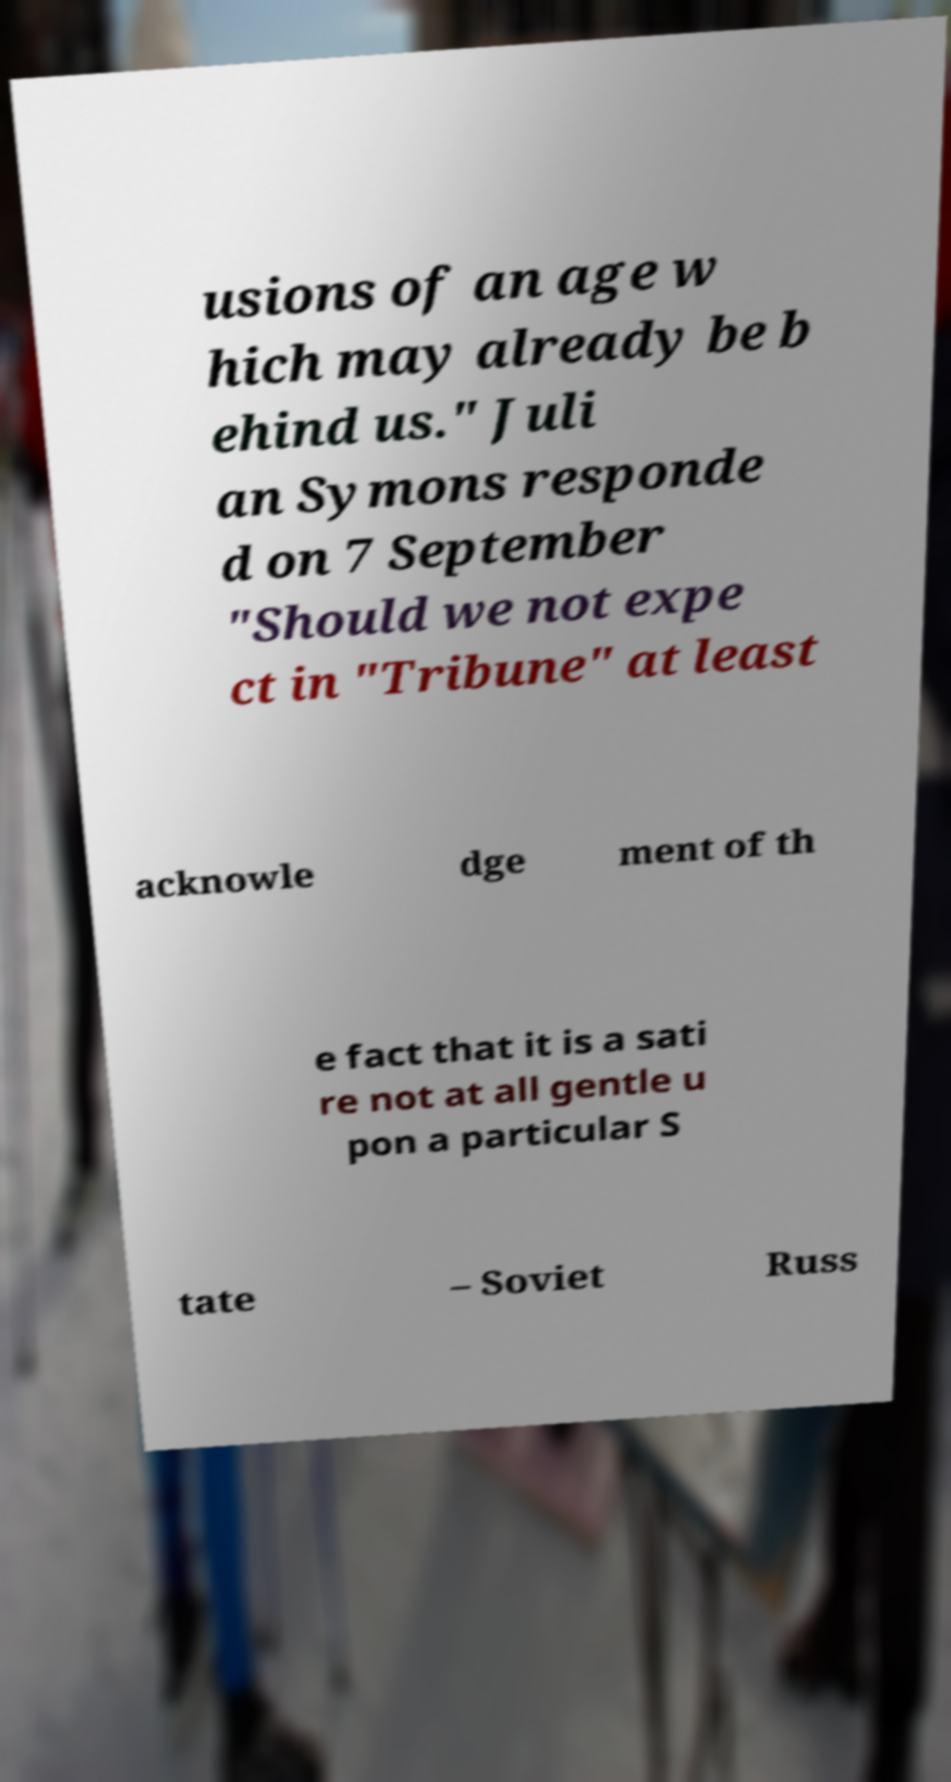Can you read and provide the text displayed in the image?This photo seems to have some interesting text. Can you extract and type it out for me? usions of an age w hich may already be b ehind us." Juli an Symons responde d on 7 September "Should we not expe ct in "Tribune" at least acknowle dge ment of th e fact that it is a sati re not at all gentle u pon a particular S tate – Soviet Russ 